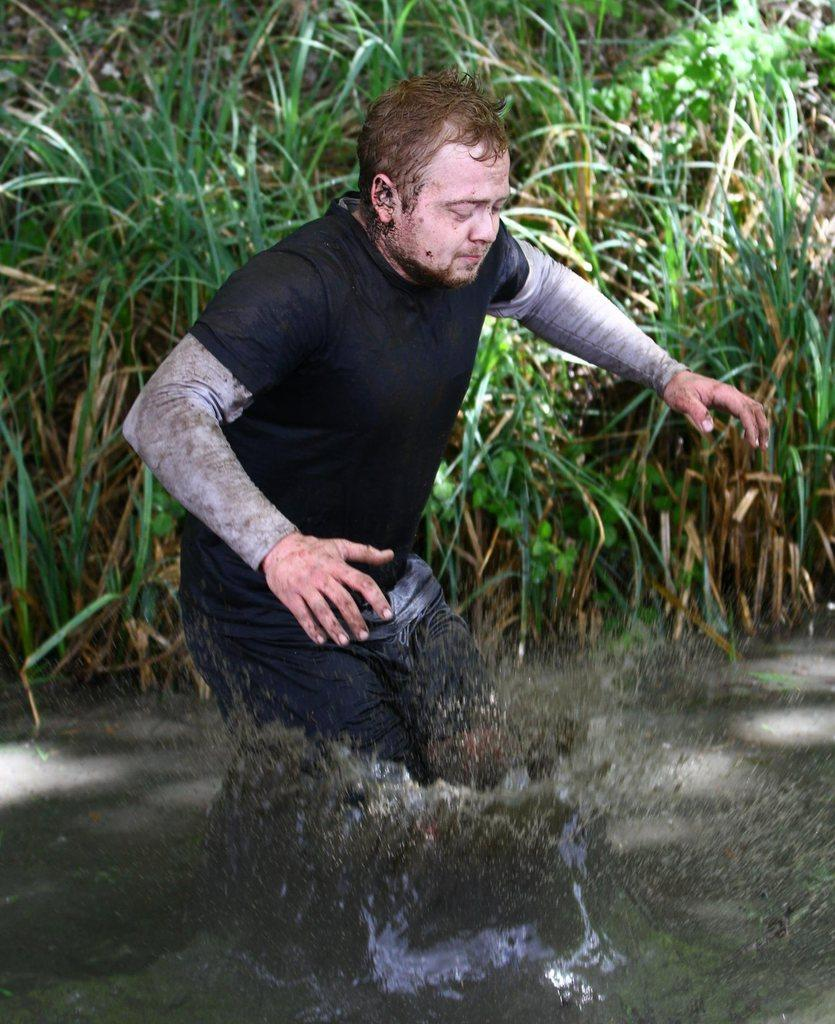Who is the main subject in the image? There is a man in the image. What is the man doing in the image? The man is walking in the image. What type of terrain is the man walking on? The man is walking in mud water in the image. What type of vegetation can be seen in the image? There is grass and plants visible in the image. What type of bulb is being used to light up the plantation in the image? There is no plantation or bulb present in the image; it features a man walking in mud water with grass and plants visible. What type of blade is the man using to cut the grass in the image? There is no blade visible in the image; the man is simply walking in mud water with grass and plants present. 